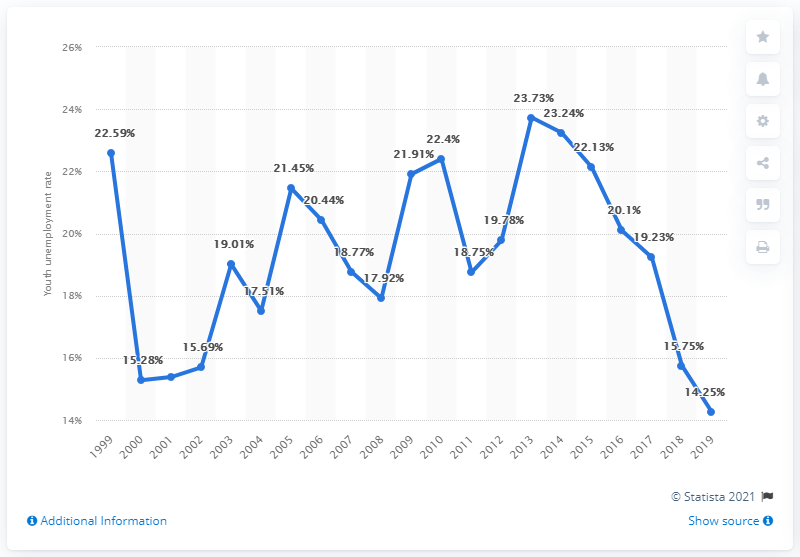Identify some key points in this picture. In 2019, the youth unemployment rate in Belgium was 14.25 percent. 